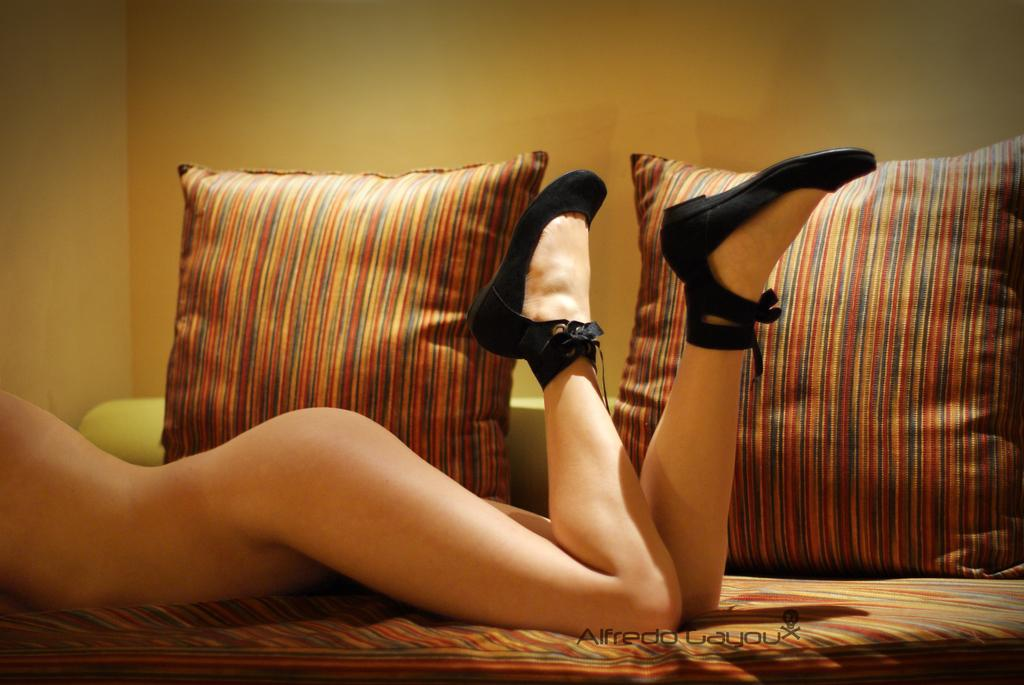What is the person in the image doing? There is a person lying on the couch in the image. What can be seen on the couch besides the person? There are pillows on the couch. What is visible at the top of the image? The top of the image is the ceiling or sky. Can you see any veins in the person's body in the image? There is no indication of visible veins in the person's body in the image. What type of air is present in the image? The image does not show any specific type of air; it simply shows the ceiling or sky at the top of the image. 